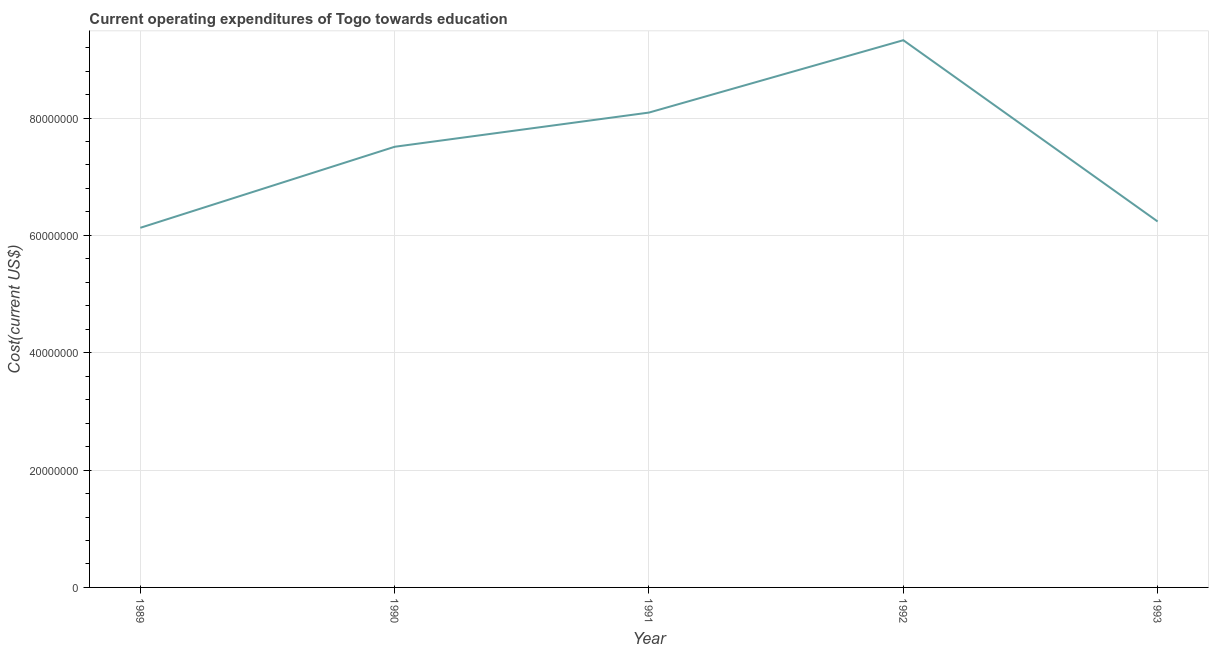What is the education expenditure in 1990?
Ensure brevity in your answer.  7.51e+07. Across all years, what is the maximum education expenditure?
Provide a short and direct response. 9.33e+07. Across all years, what is the minimum education expenditure?
Provide a succinct answer. 6.13e+07. In which year was the education expenditure maximum?
Make the answer very short. 1992. In which year was the education expenditure minimum?
Give a very brief answer. 1989. What is the sum of the education expenditure?
Give a very brief answer. 3.73e+08. What is the difference between the education expenditure in 1989 and 1991?
Offer a very short reply. -1.96e+07. What is the average education expenditure per year?
Keep it short and to the point. 7.46e+07. What is the median education expenditure?
Your answer should be very brief. 7.51e+07. Do a majority of the years between 1993 and 1991 (inclusive) have education expenditure greater than 88000000 US$?
Give a very brief answer. No. What is the ratio of the education expenditure in 1992 to that in 1993?
Ensure brevity in your answer.  1.5. Is the education expenditure in 1990 less than that in 1992?
Your answer should be very brief. Yes. What is the difference between the highest and the second highest education expenditure?
Offer a terse response. 1.23e+07. Is the sum of the education expenditure in 1991 and 1993 greater than the maximum education expenditure across all years?
Offer a very short reply. Yes. What is the difference between the highest and the lowest education expenditure?
Your response must be concise. 3.20e+07. In how many years, is the education expenditure greater than the average education expenditure taken over all years?
Provide a succinct answer. 3. Does the education expenditure monotonically increase over the years?
Offer a very short reply. No. How many lines are there?
Give a very brief answer. 1. Does the graph contain any zero values?
Your response must be concise. No. Does the graph contain grids?
Your response must be concise. Yes. What is the title of the graph?
Offer a terse response. Current operating expenditures of Togo towards education. What is the label or title of the Y-axis?
Your response must be concise. Cost(current US$). What is the Cost(current US$) in 1989?
Keep it short and to the point. 6.13e+07. What is the Cost(current US$) in 1990?
Offer a very short reply. 7.51e+07. What is the Cost(current US$) of 1991?
Your response must be concise. 8.09e+07. What is the Cost(current US$) of 1992?
Your answer should be compact. 9.33e+07. What is the Cost(current US$) of 1993?
Keep it short and to the point. 6.24e+07. What is the difference between the Cost(current US$) in 1989 and 1990?
Provide a succinct answer. -1.38e+07. What is the difference between the Cost(current US$) in 1989 and 1991?
Your response must be concise. -1.96e+07. What is the difference between the Cost(current US$) in 1989 and 1992?
Make the answer very short. -3.20e+07. What is the difference between the Cost(current US$) in 1989 and 1993?
Make the answer very short. -1.08e+06. What is the difference between the Cost(current US$) in 1990 and 1991?
Your answer should be compact. -5.83e+06. What is the difference between the Cost(current US$) in 1990 and 1992?
Make the answer very short. -1.82e+07. What is the difference between the Cost(current US$) in 1990 and 1993?
Your answer should be compact. 1.27e+07. What is the difference between the Cost(current US$) in 1991 and 1992?
Make the answer very short. -1.23e+07. What is the difference between the Cost(current US$) in 1991 and 1993?
Your response must be concise. 1.86e+07. What is the difference between the Cost(current US$) in 1992 and 1993?
Make the answer very short. 3.09e+07. What is the ratio of the Cost(current US$) in 1989 to that in 1990?
Offer a very short reply. 0.82. What is the ratio of the Cost(current US$) in 1989 to that in 1991?
Provide a succinct answer. 0.76. What is the ratio of the Cost(current US$) in 1989 to that in 1992?
Provide a succinct answer. 0.66. What is the ratio of the Cost(current US$) in 1989 to that in 1993?
Your answer should be very brief. 0.98. What is the ratio of the Cost(current US$) in 1990 to that in 1991?
Give a very brief answer. 0.93. What is the ratio of the Cost(current US$) in 1990 to that in 1992?
Provide a succinct answer. 0.81. What is the ratio of the Cost(current US$) in 1990 to that in 1993?
Provide a succinct answer. 1.2. What is the ratio of the Cost(current US$) in 1991 to that in 1992?
Provide a short and direct response. 0.87. What is the ratio of the Cost(current US$) in 1991 to that in 1993?
Give a very brief answer. 1.3. What is the ratio of the Cost(current US$) in 1992 to that in 1993?
Offer a very short reply. 1.5. 